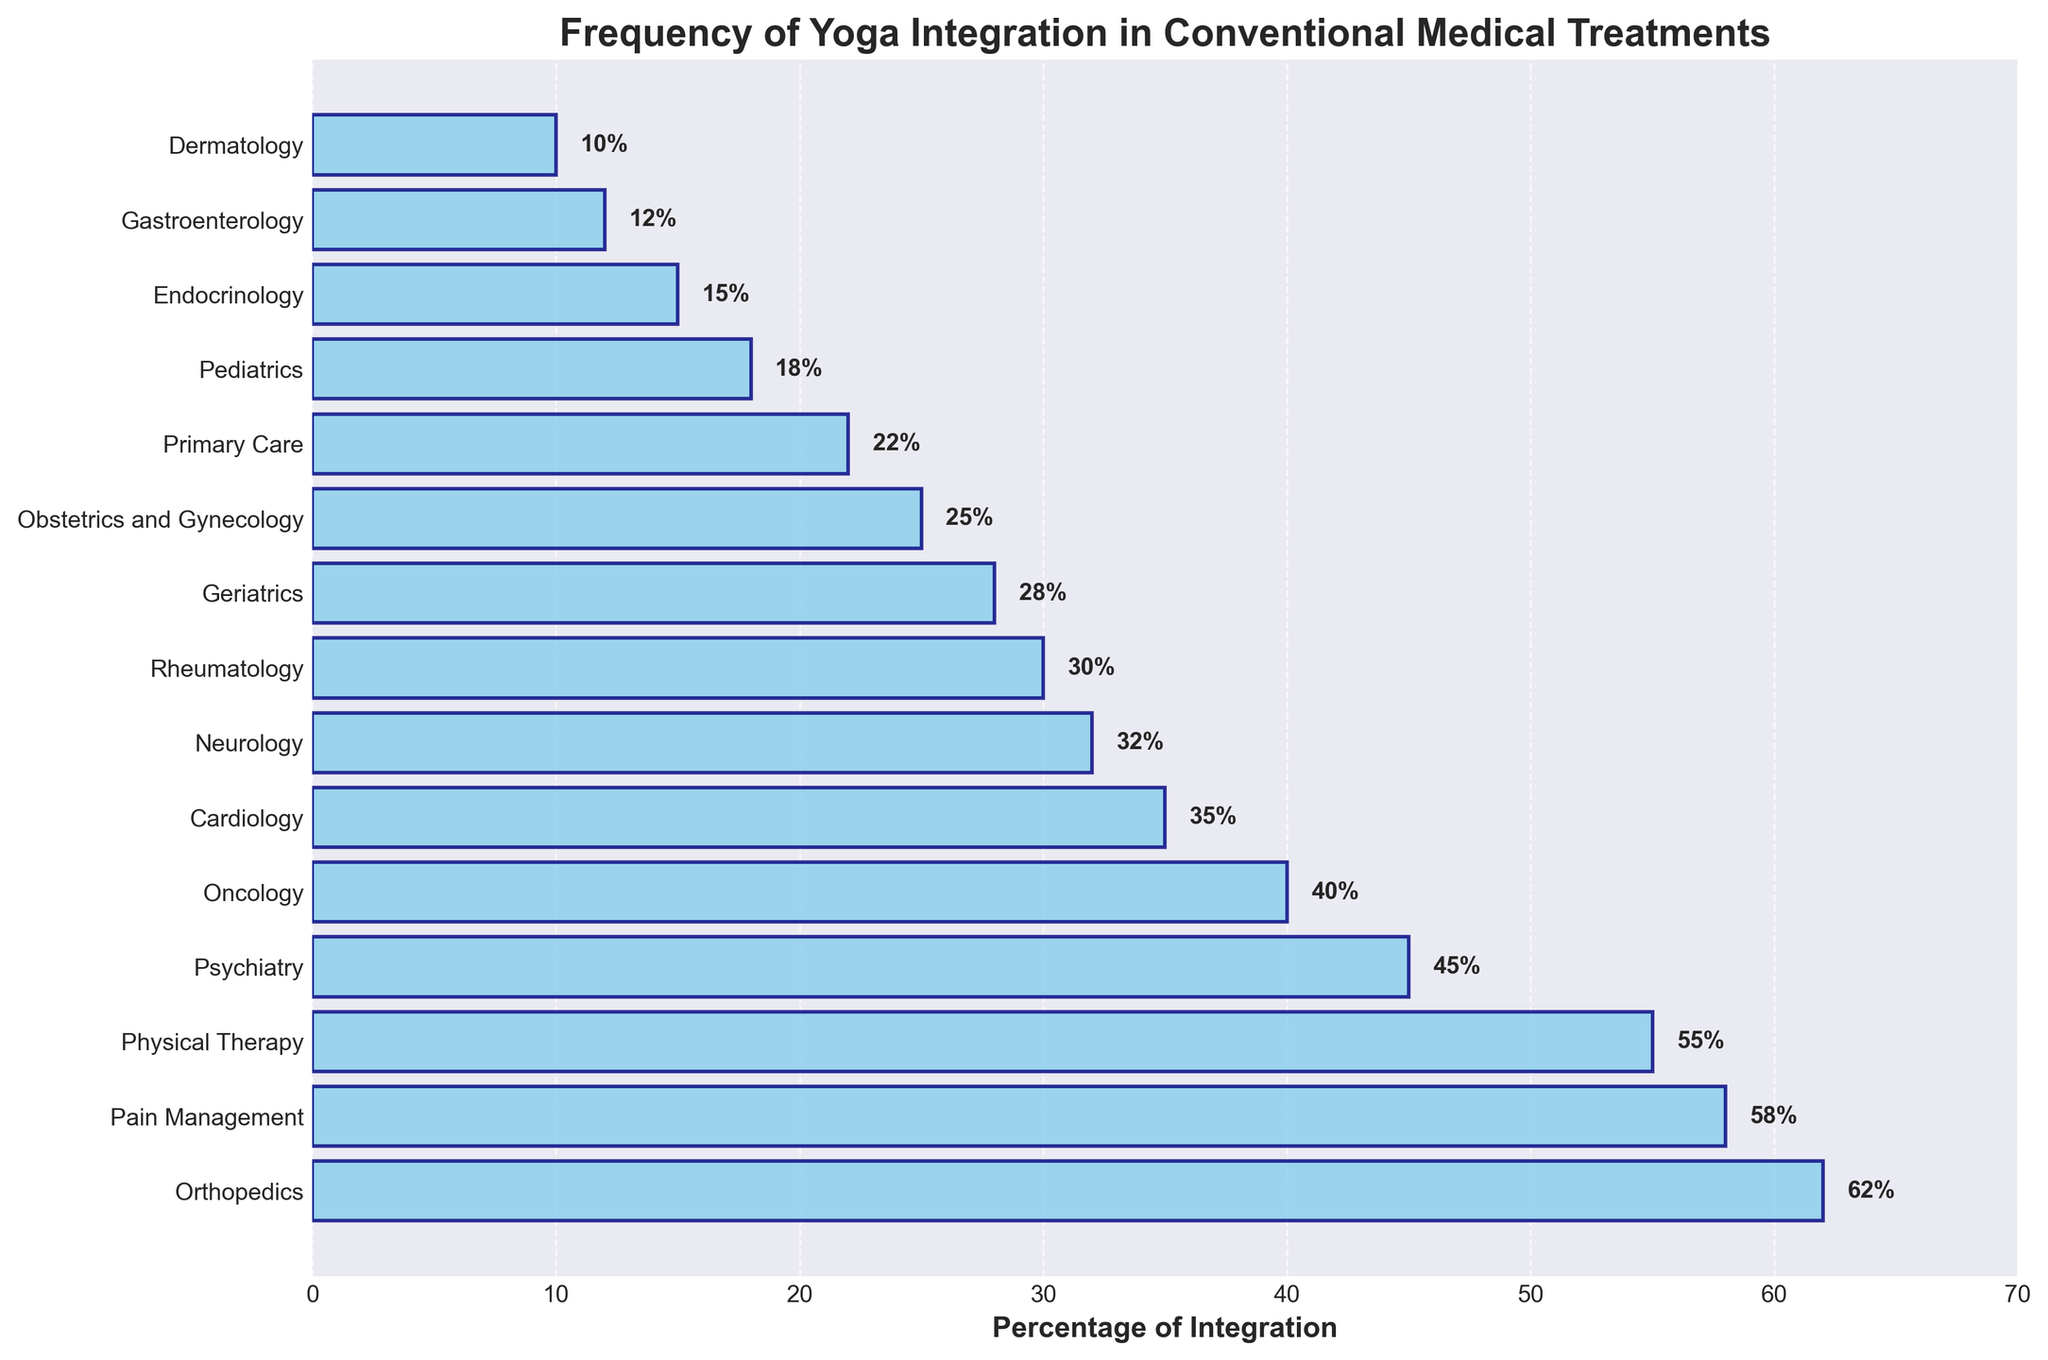What specialty has the highest percentage of yoga integration? The bar for Orthopedics is the longest and its percentage label is the highest, which is 62%.
Answer: Orthopedics What is the percentage difference in yoga integration between Oncology and Cardiology? The percentage for Oncology is 40% and for Cardiology is 35%. The difference is 40% - 35% = 5%.
Answer: 5% Which specialty has a slightly higher percentage of yoga integration, Psychiatry or Physical Therapy? Psychiatry has 45% while Physical Therapy has 55%, so Physical Therapy is higher.
Answer: Physical Therapy How many specialties have more than 30% yoga integration? By visually counting the bars with a percentage greater than 30%, we have Orthopedics, Pain Management, Physical Therapy, Psychiatry, Oncology, and Cardiology — a total of 6 specialties.
Answer: 6 What is the median percentage of yoga integration across all specialties? Arrange the percentages in ascending order: 10, 12, 15, 18, 22, 25, 28, 30, 32, 35, 40, 45, 55, 58, 62. The median is the middle value, which is 30.
Answer: 30 Which specialty has the least integration of yoga? The shortest bar corresponds to Dermatology, with a percentage of 10%.
Answer: Dermatology What is the sum of the percentages for Geriatrics and Obstetrics and Gynecology? Geriatrics has 28% and Obstetrics and Gynecology has 25%. The sum is 28% + 25% = 53%.
Answer: 53% Compare the visibility of the text labels on the bars for Endocrinology and Dermatology. Which one is more legible? The text labels are positioned outside the bars. Both are fairly short, but Dermatology's 10% label aligns more to the edge than Endocrinology's 15%, making Endocrinology marginally clearer.
Answer: Endocrinology How does the integration of yoga in Pain Management compare with that in Endocrinology? Pain Management has 58% and Endocrinology has 15%. Pain Management is significantly higher than Endocrinology.
Answer: Pain Management is significantly higher 